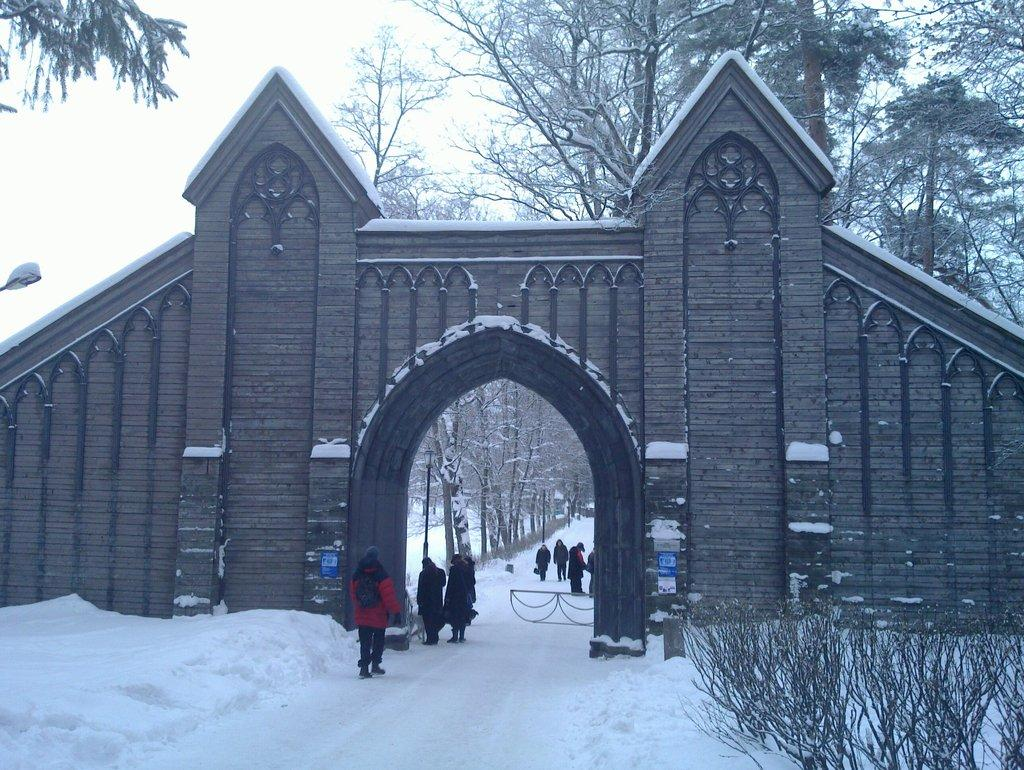What type of structure can be seen in the image? There is an arch and a wall in the image. What is the weather like in the image? There is snow in the image, indicating a cold or wintery environment. What type of vegetation is present in the image? There are trees in the image. What type of lighting is present in the image? There are street lights in the image. Are there any people visible in the image? Yes, there are people on the road in the image. What can be seen in the background of the image? The sky is visible in the background of the image. What position does the pencil hold in the image? There is no pencil present in the image. Can you tell me how many doors are visible in the image? There is no door visible in the image. 